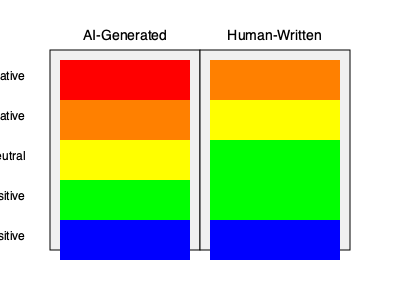Based on the sentiment analysis heat maps for AI-generated and human-written literature, what key difference can be observed in the distribution of very negative sentiments? To answer this question, we need to analyze the heat maps for both AI-generated and human-written literature:

1. Identify the "Very Negative" sentiment row:
   - This is the topmost row in both heat maps, represented by red.

2. Compare the intensity of red in the "Very Negative" row:
   - AI-Generated: The red color is more intense (pure red).
   - Human-Written: The red color is less intense (orange-red).

3. Interpret the color intensity:
   - More intense red indicates a higher frequency or stronger presence of very negative sentiments.
   - Less intense red (orange-red) indicates a lower frequency or weaker presence of very negative sentiments.

4. Draw a conclusion:
   - The AI-generated literature shows a higher presence of very negative sentiments compared to human-written literature.

This difference suggests that AI-generated content tends to produce more extreme negative sentiments than human-written content, which could be an important finding for a doctoral candidate researching AI-generated literature and its influence on the novel as a form.
Answer: AI-generated literature exhibits more very negative sentiments than human-written literature. 